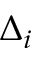Convert formula to latex. <formula><loc_0><loc_0><loc_500><loc_500>\Delta _ { i }</formula> 